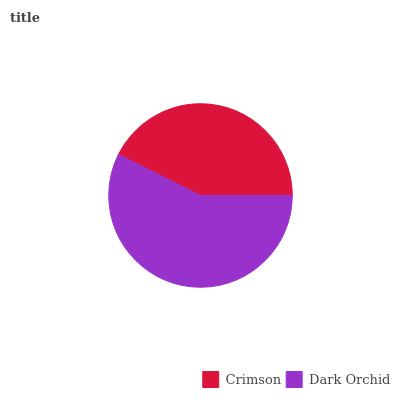Is Crimson the minimum?
Answer yes or no. Yes. Is Dark Orchid the maximum?
Answer yes or no. Yes. Is Dark Orchid the minimum?
Answer yes or no. No. Is Dark Orchid greater than Crimson?
Answer yes or no. Yes. Is Crimson less than Dark Orchid?
Answer yes or no. Yes. Is Crimson greater than Dark Orchid?
Answer yes or no. No. Is Dark Orchid less than Crimson?
Answer yes or no. No. Is Dark Orchid the high median?
Answer yes or no. Yes. Is Crimson the low median?
Answer yes or no. Yes. Is Crimson the high median?
Answer yes or no. No. Is Dark Orchid the low median?
Answer yes or no. No. 